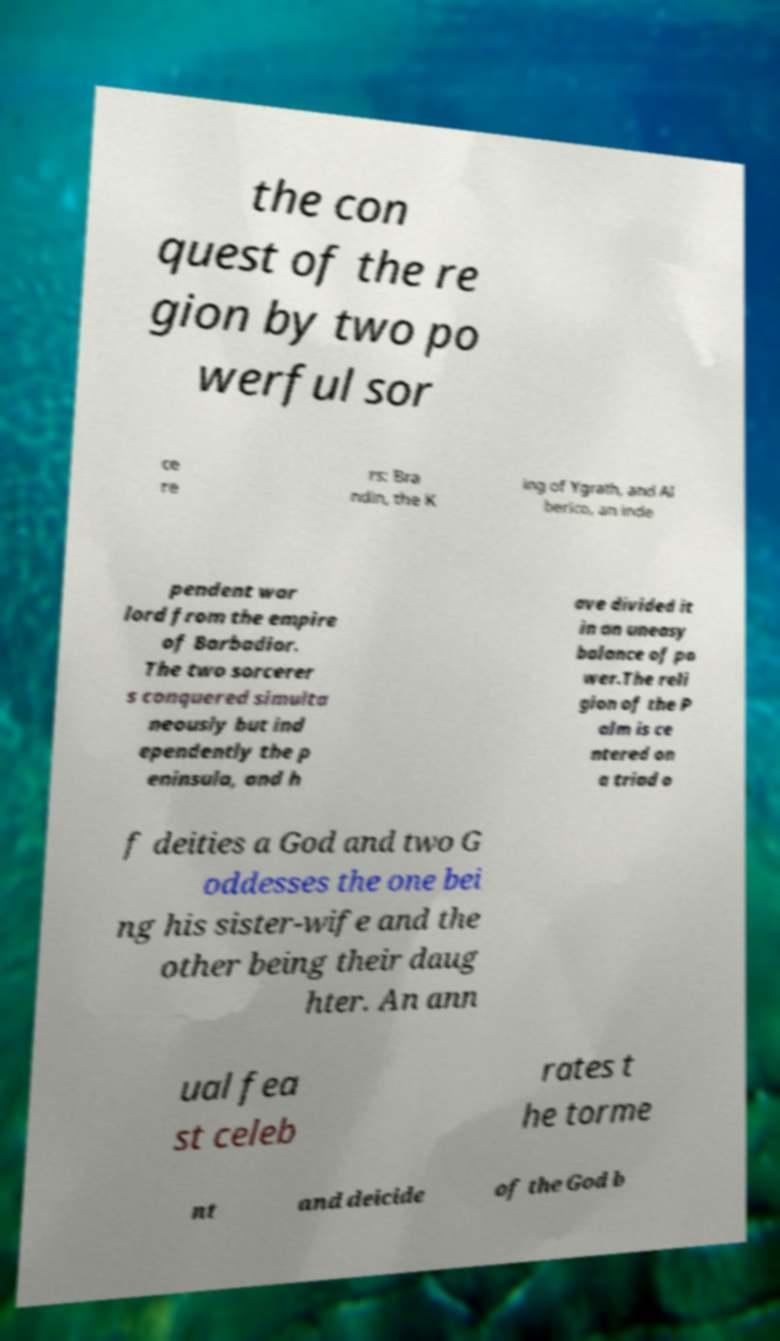Please identify and transcribe the text found in this image. the con quest of the re gion by two po werful sor ce re rs: Bra ndin, the K ing of Ygrath, and Al berico, an inde pendent war lord from the empire of Barbadior. The two sorcerer s conquered simulta neously but ind ependently the p eninsula, and h ave divided it in an uneasy balance of po wer.The reli gion of the P alm is ce ntered on a triad o f deities a God and two G oddesses the one bei ng his sister-wife and the other being their daug hter. An ann ual fea st celeb rates t he torme nt and deicide of the God b 